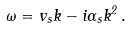<formula> <loc_0><loc_0><loc_500><loc_500>\omega = { v _ { s } } k - i \Gamma _ { s } k ^ { 2 } \, .</formula> 